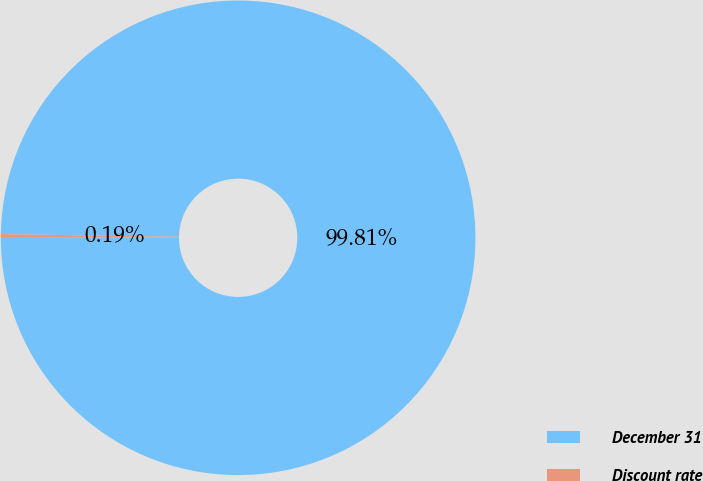<chart> <loc_0><loc_0><loc_500><loc_500><pie_chart><fcel>December 31<fcel>Discount rate<nl><fcel>99.81%<fcel>0.19%<nl></chart> 